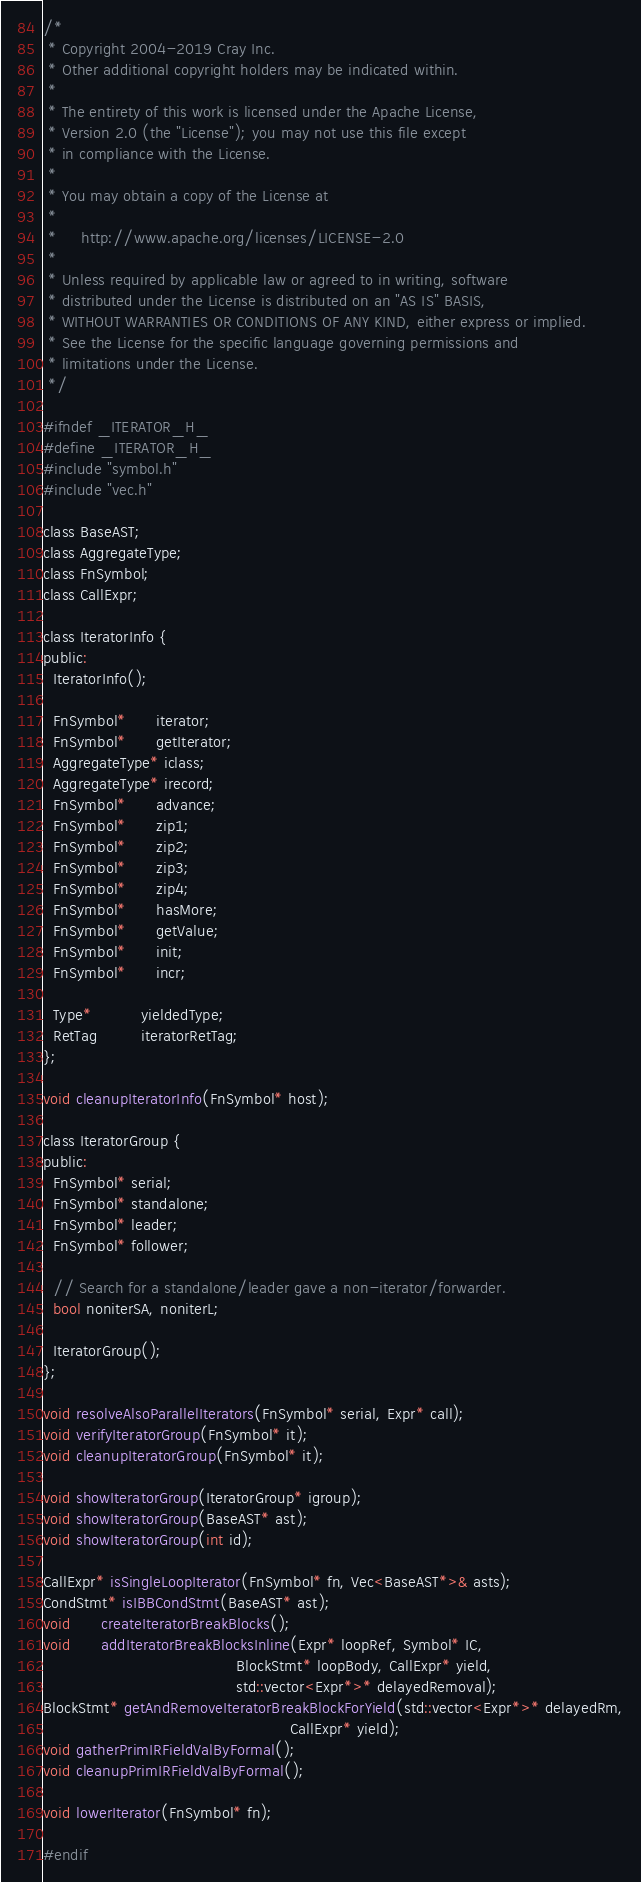Convert code to text. <code><loc_0><loc_0><loc_500><loc_500><_C_>/*
 * Copyright 2004-2019 Cray Inc.
 * Other additional copyright holders may be indicated within.
 * 
 * The entirety of this work is licensed under the Apache License,
 * Version 2.0 (the "License"); you may not use this file except
 * in compliance with the License.
 * 
 * You may obtain a copy of the License at
 * 
 *     http://www.apache.org/licenses/LICENSE-2.0
 * 
 * Unless required by applicable law or agreed to in writing, software
 * distributed under the License is distributed on an "AS IS" BASIS,
 * WITHOUT WARRANTIES OR CONDITIONS OF ANY KIND, either express or implied.
 * See the License for the specific language governing permissions and
 * limitations under the License.
 */

#ifndef _ITERATOR_H_
#define _ITERATOR_H_
#include "symbol.h"
#include "vec.h"

class BaseAST;
class AggregateType;
class FnSymbol;
class CallExpr;

class IteratorInfo {
public:
  IteratorInfo();

  FnSymbol*      iterator;
  FnSymbol*      getIterator;
  AggregateType* iclass;
  AggregateType* irecord;
  FnSymbol*      advance;
  FnSymbol*      zip1;
  FnSymbol*      zip2;
  FnSymbol*      zip3;
  FnSymbol*      zip4;
  FnSymbol*      hasMore;
  FnSymbol*      getValue;
  FnSymbol*      init;
  FnSymbol*      incr;

  Type*          yieldedType;
  RetTag         iteratorRetTag;
};

void cleanupIteratorInfo(FnSymbol* host);

class IteratorGroup {
public:
  FnSymbol* serial;
  FnSymbol* standalone;
  FnSymbol* leader;
  FnSymbol* follower;

  // Search for a standalone/leader gave a non-iterator/forwarder.
  bool noniterSA, noniterL;

  IteratorGroup();
};

void resolveAlsoParallelIterators(FnSymbol* serial, Expr* call);
void verifyIteratorGroup(FnSymbol* it);
void cleanupIteratorGroup(FnSymbol* it);

void showIteratorGroup(IteratorGroup* igroup);
void showIteratorGroup(BaseAST* ast);
void showIteratorGroup(int id);

CallExpr* isSingleLoopIterator(FnSymbol* fn, Vec<BaseAST*>& asts);
CondStmt* isIBBCondStmt(BaseAST* ast);
void      createIteratorBreakBlocks();
void      addIteratorBreakBlocksInline(Expr* loopRef, Symbol* IC,
                                       BlockStmt* loopBody, CallExpr* yield,
                                       std::vector<Expr*>* delayedRemoval);
BlockStmt* getAndRemoveIteratorBreakBlockForYield(std::vector<Expr*>* delayedRm,
                                                  CallExpr* yield);
void gatherPrimIRFieldValByFormal();
void cleanupPrimIRFieldValByFormal();

void lowerIterator(FnSymbol* fn);

#endif
</code> 